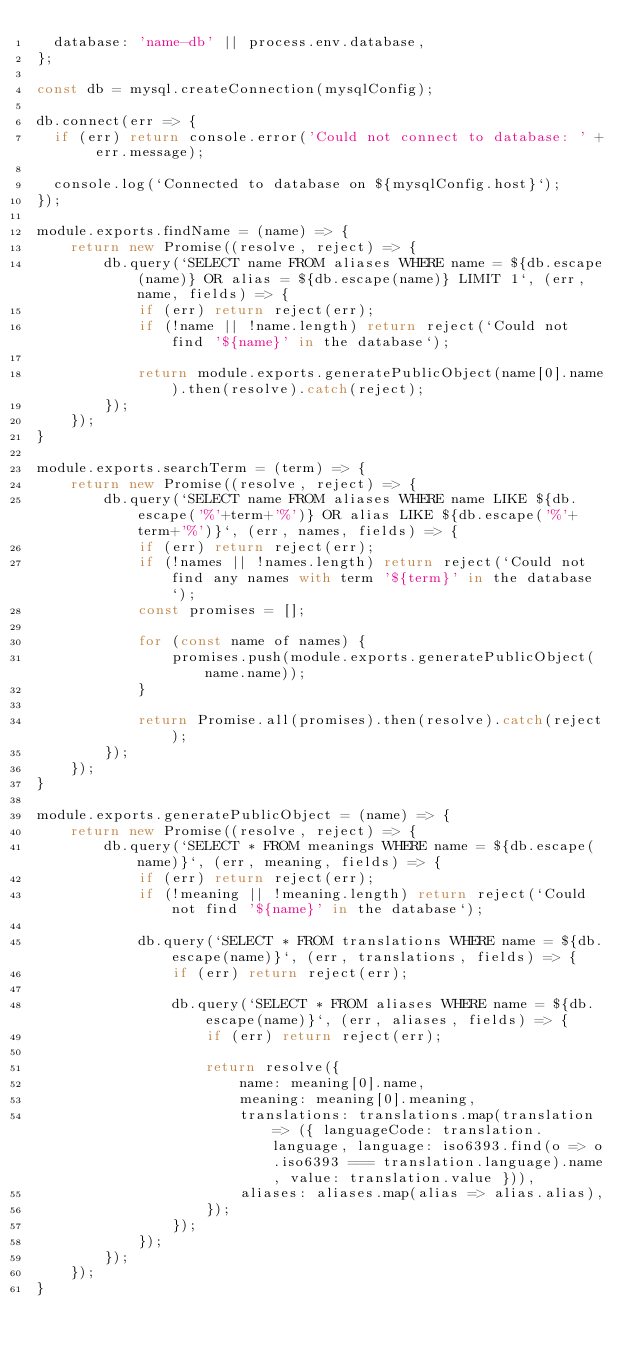Convert code to text. <code><loc_0><loc_0><loc_500><loc_500><_JavaScript_>  database: 'name-db' || process.env.database,
};

const db = mysql.createConnection(mysqlConfig);

db.connect(err => {
  if (err) return console.error('Could not connect to database: ' + err.message);

  console.log(`Connected to database on ${mysqlConfig.host}`);
});

module.exports.findName = (name) => {
    return new Promise((resolve, reject) => {
        db.query(`SELECT name FROM aliases WHERE name = ${db.escape(name)} OR alias = ${db.escape(name)} LIMIT 1`, (err, name, fields) => {
            if (err) return reject(err);
            if (!name || !name.length) return reject(`Could not find '${name}' in the database`);

            return module.exports.generatePublicObject(name[0].name).then(resolve).catch(reject);
        });
    });
}

module.exports.searchTerm = (term) => {
    return new Promise((resolve, reject) => {
        db.query(`SELECT name FROM aliases WHERE name LIKE ${db.escape('%'+term+'%')} OR alias LIKE ${db.escape('%'+term+'%')}`, (err, names, fields) => {
            if (err) return reject(err);
            if (!names || !names.length) return reject(`Could not find any names with term '${term}' in the database`);
            const promises = [];

            for (const name of names) {
                promises.push(module.exports.generatePublicObject(name.name));
            }

            return Promise.all(promises).then(resolve).catch(reject);
        });
    });
}

module.exports.generatePublicObject = (name) => {
    return new Promise((resolve, reject) => {
        db.query(`SELECT * FROM meanings WHERE name = ${db.escape(name)}`, (err, meaning, fields) => {
            if (err) return reject(err);
            if (!meaning || !meaning.length) return reject(`Could not find '${name}' in the database`);

            db.query(`SELECT * FROM translations WHERE name = ${db.escape(name)}`, (err, translations, fields) => {
                if (err) return reject(err);

                db.query(`SELECT * FROM aliases WHERE name = ${db.escape(name)}`, (err, aliases, fields) => {
                    if (err) return reject(err);

                    return resolve({
                        name: meaning[0].name,
                        meaning: meaning[0].meaning,
                        translations: translations.map(translation => ({ languageCode: translation.language, language: iso6393.find(o => o.iso6393 === translation.language).name, value: translation.value })),
                        aliases: aliases.map(alias => alias.alias),
                    });
                });
            });
        });
    });
}</code> 